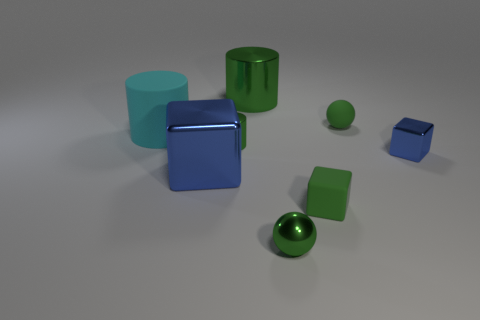Add 2 big metallic cubes. How many objects exist? 10 Subtract all spheres. How many objects are left? 6 Add 3 tiny blue shiny objects. How many tiny blue shiny objects are left? 4 Add 6 matte cylinders. How many matte cylinders exist? 7 Subtract 1 green blocks. How many objects are left? 7 Subtract all tiny green matte blocks. Subtract all large yellow shiny spheres. How many objects are left? 7 